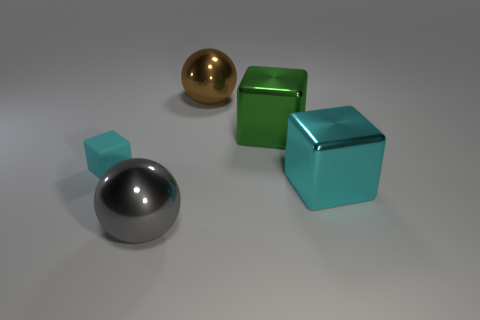The large shiny object that is both left of the large green metal cube and behind the small matte thing has what shape? The large shiny object positioned to the left of the green cube and behind the smaller object has a spherical shape, reflecting light on its smooth and curved surface. 